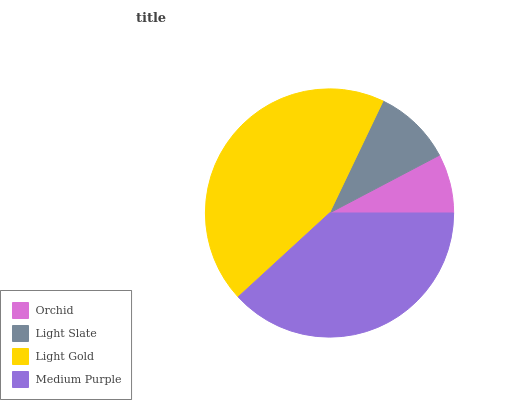Is Orchid the minimum?
Answer yes or no. Yes. Is Light Gold the maximum?
Answer yes or no. Yes. Is Light Slate the minimum?
Answer yes or no. No. Is Light Slate the maximum?
Answer yes or no. No. Is Light Slate greater than Orchid?
Answer yes or no. Yes. Is Orchid less than Light Slate?
Answer yes or no. Yes. Is Orchid greater than Light Slate?
Answer yes or no. No. Is Light Slate less than Orchid?
Answer yes or no. No. Is Medium Purple the high median?
Answer yes or no. Yes. Is Light Slate the low median?
Answer yes or no. Yes. Is Orchid the high median?
Answer yes or no. No. Is Light Gold the low median?
Answer yes or no. No. 